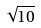<formula> <loc_0><loc_0><loc_500><loc_500>\sqrt { 1 0 }</formula> 